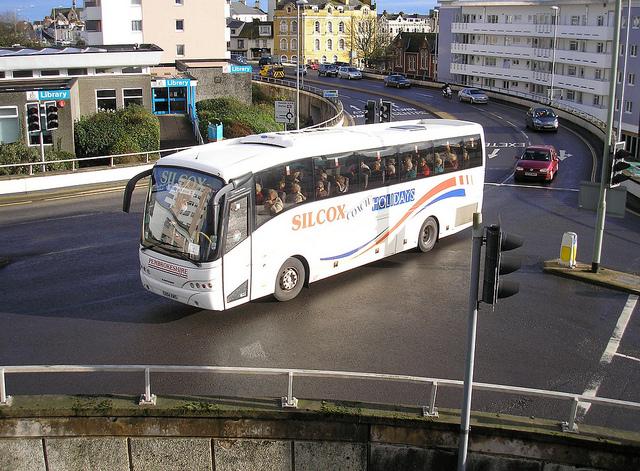What is the bus company's name?
Quick response, please. Silcox. Does the bus have rust?
Concise answer only. No. How many buses are in the photo?
Keep it brief. 1. Is the bus full or empty?
Quick response, please. Full. What is in the grill of the car?
Concise answer only. Nothing. 